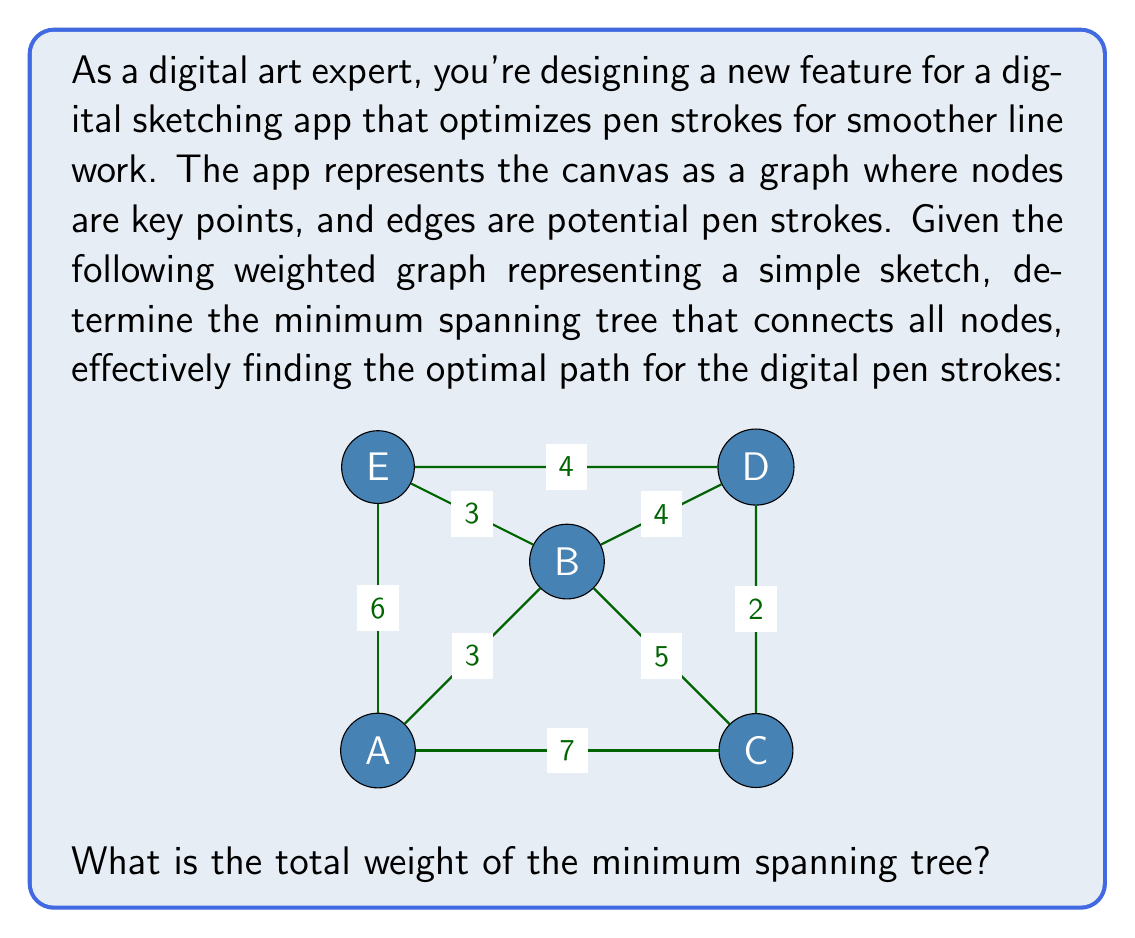Teach me how to tackle this problem. To solve this problem, we'll use Kruskal's algorithm to find the minimum spanning tree (MST) of the given graph. This algorithm works by sorting all edges by weight and then adding them to the MST if they don't create a cycle, until all nodes are connected.

Steps:
1. List all edges with their weights:
   AB: 3, BC: 5, CD: 2, DE: 4, EA: 6, BD: 4, BE: 3, AC: 7

2. Sort edges by weight (ascending order):
   CD: 2, AB: 3, BE: 3, BD: 4, DE: 4, BC: 5, EA: 6, AC: 7

3. Add edges to the MST:
   - Add CD (2)
   - Add AB (3)
   - Add BE (3)
   - Add DE (4) - This completes the MST as all nodes are now connected

The resulting MST consists of edges: CD, AB, BE, and DE.

Total weight calculation:
$$ \text{Total Weight} = w_{CD} + w_{AB} + w_{BE} + w_{DE} $$
$$ \text{Total Weight} = 2 + 3 + 3 + 4 = 12 $$

Therefore, the total weight of the minimum spanning tree is 12.
Answer: 12 